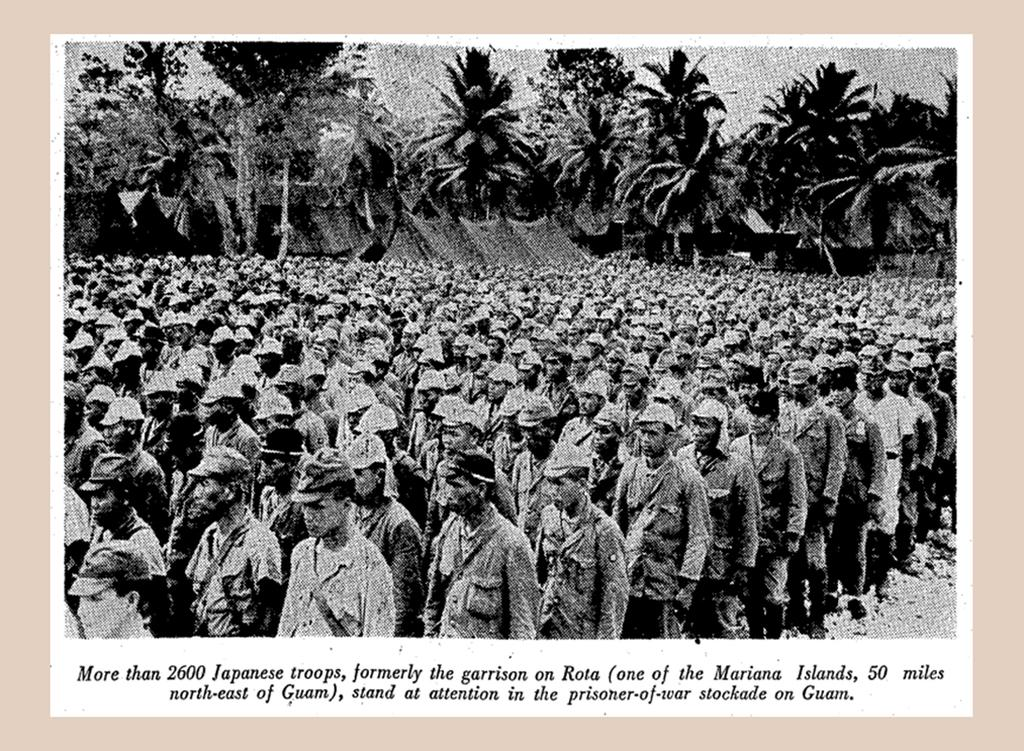<image>
Offer a succinct explanation of the picture presented. the number 2600 is on the photo of the people 